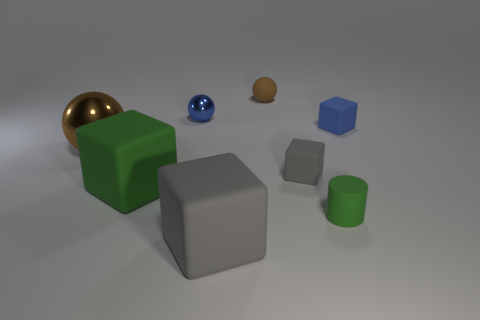Subtract all cyan cubes. Subtract all brown spheres. How many cubes are left? 4 Add 1 green matte things. How many objects exist? 9 Subtract all balls. How many objects are left? 5 Subtract 0 yellow blocks. How many objects are left? 8 Subtract all big blue rubber blocks. Subtract all tiny brown matte spheres. How many objects are left? 7 Add 1 small blue spheres. How many small blue spheres are left? 2 Add 8 brown things. How many brown things exist? 10 